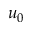Convert formula to latex. <formula><loc_0><loc_0><loc_500><loc_500>u _ { 0 }</formula> 